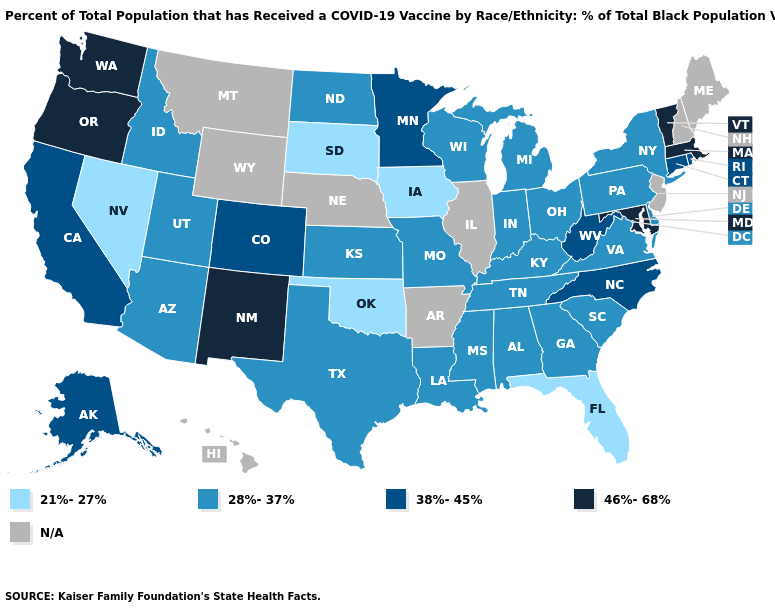Name the states that have a value in the range 38%-45%?
Give a very brief answer. Alaska, California, Colorado, Connecticut, Minnesota, North Carolina, Rhode Island, West Virginia. What is the value of Arkansas?
Short answer required. N/A. Among the states that border Pennsylvania , which have the highest value?
Short answer required. Maryland. What is the highest value in states that border Vermont?
Be succinct. 46%-68%. What is the highest value in the USA?
Short answer required. 46%-68%. Is the legend a continuous bar?
Be succinct. No. Does the map have missing data?
Be succinct. Yes. Name the states that have a value in the range N/A?
Short answer required. Arkansas, Hawaii, Illinois, Maine, Montana, Nebraska, New Hampshire, New Jersey, Wyoming. Name the states that have a value in the range 28%-37%?
Answer briefly. Alabama, Arizona, Delaware, Georgia, Idaho, Indiana, Kansas, Kentucky, Louisiana, Michigan, Mississippi, Missouri, New York, North Dakota, Ohio, Pennsylvania, South Carolina, Tennessee, Texas, Utah, Virginia, Wisconsin. Name the states that have a value in the range N/A?
Answer briefly. Arkansas, Hawaii, Illinois, Maine, Montana, Nebraska, New Hampshire, New Jersey, Wyoming. What is the lowest value in the Northeast?
Quick response, please. 28%-37%. Among the states that border Delaware , which have the highest value?
Keep it brief. Maryland. Among the states that border Oklahoma , which have the highest value?
Quick response, please. New Mexico. 